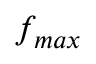<formula> <loc_0><loc_0><loc_500><loc_500>f _ { \max }</formula> 